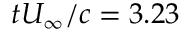Convert formula to latex. <formula><loc_0><loc_0><loc_500><loc_500>t U _ { \infty } / c = 3 . 2 3</formula> 